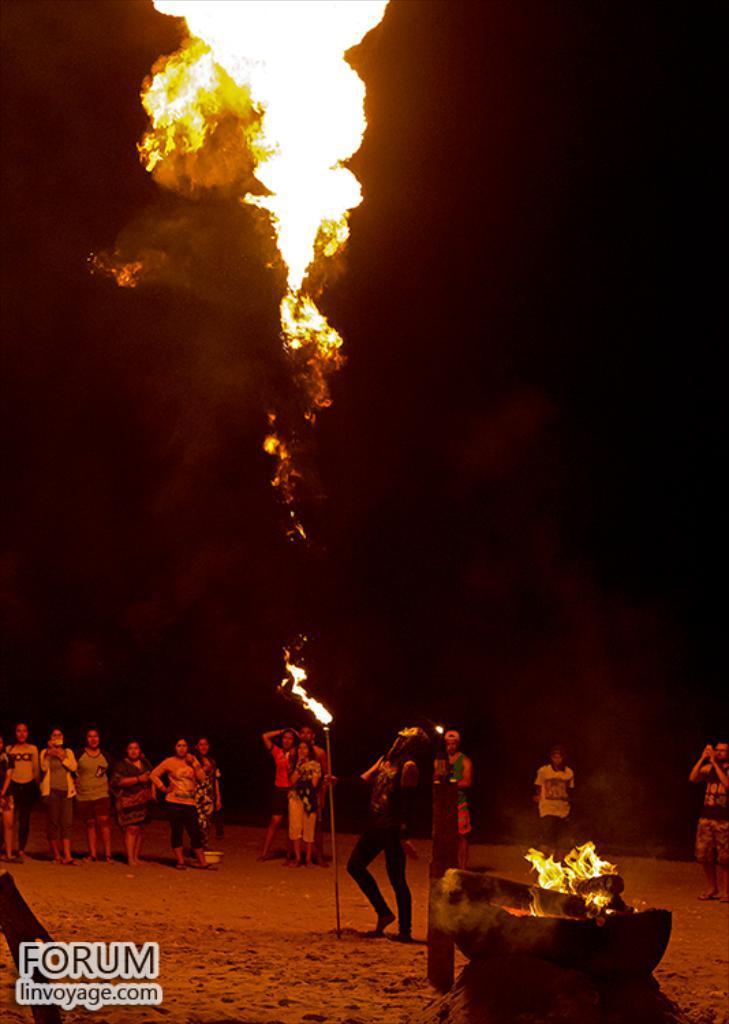How many people are in the image? There is a group of people in the image, but the exact number is not specified. What are the people doing in the image? The people are standing together and watching a fire. Can you describe the fire in the image? The fire is blowing upside down, and there is a big pot in front of the people with a lot of fire in it. What color is the crayon being used to draw on the thumb in the image? There is no crayon or thumb present in the image; it features a group of people watching a fire with a big pot in front of them. 